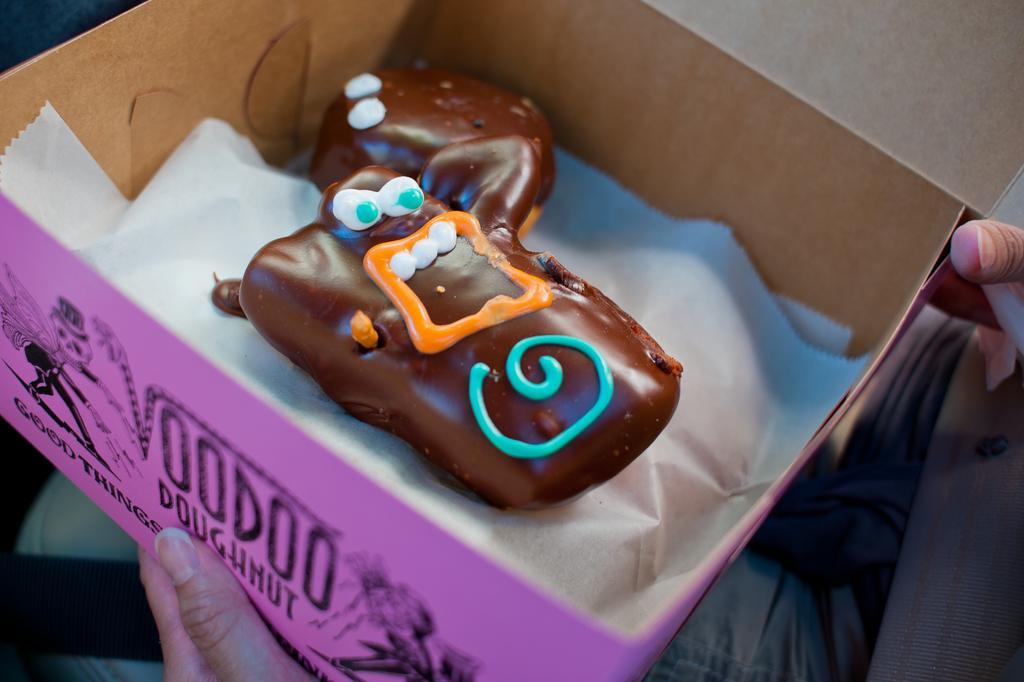Describe this image in one or two sentences. In this image there is a food item and paper in the box and the box is in the person's hand. 